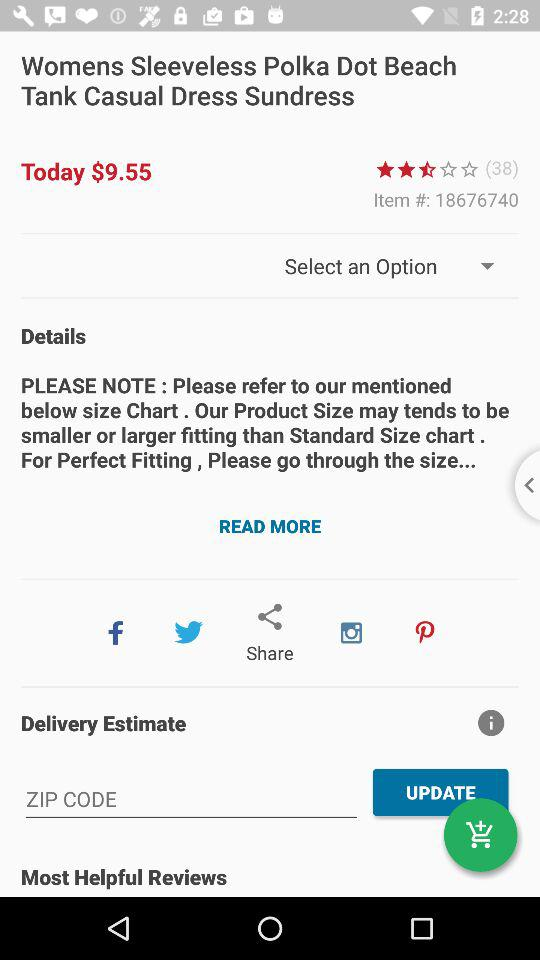What is the price of the product? The price of the product is $9.55. 